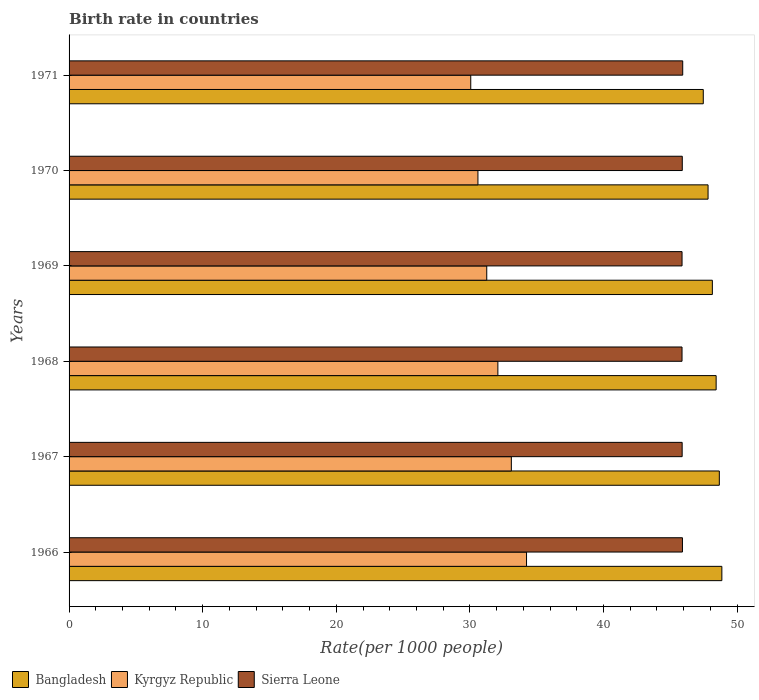What is the label of the 4th group of bars from the top?
Your answer should be compact. 1968. What is the birth rate in Kyrgyz Republic in 1971?
Provide a short and direct response. 30.06. Across all years, what is the maximum birth rate in Kyrgyz Republic?
Offer a terse response. 34.24. Across all years, what is the minimum birth rate in Sierra Leone?
Your response must be concise. 45.88. In which year was the birth rate in Kyrgyz Republic maximum?
Your answer should be compact. 1966. What is the total birth rate in Bangladesh in the graph?
Your response must be concise. 289.39. What is the difference between the birth rate in Kyrgyz Republic in 1969 and that in 1971?
Ensure brevity in your answer.  1.2. What is the difference between the birth rate in Bangladesh in 1967 and the birth rate in Sierra Leone in 1968?
Make the answer very short. 2.79. What is the average birth rate in Sierra Leone per year?
Ensure brevity in your answer.  45.9. In the year 1970, what is the difference between the birth rate in Kyrgyz Republic and birth rate in Bangladesh?
Your response must be concise. -17.22. What is the ratio of the birth rate in Bangladesh in 1967 to that in 1971?
Keep it short and to the point. 1.03. Is the birth rate in Kyrgyz Republic in 1967 less than that in 1970?
Keep it short and to the point. No. What is the difference between the highest and the second highest birth rate in Kyrgyz Republic?
Offer a very short reply. 1.14. What is the difference between the highest and the lowest birth rate in Sierra Leone?
Offer a terse response. 0.05. In how many years, is the birth rate in Kyrgyz Republic greater than the average birth rate in Kyrgyz Republic taken over all years?
Keep it short and to the point. 3. Is the sum of the birth rate in Kyrgyz Republic in 1966 and 1971 greater than the maximum birth rate in Bangladesh across all years?
Offer a terse response. Yes. What does the 2nd bar from the bottom in 1968 represents?
Make the answer very short. Kyrgyz Republic. Does the graph contain grids?
Offer a very short reply. No. Where does the legend appear in the graph?
Your response must be concise. Bottom left. How are the legend labels stacked?
Offer a terse response. Horizontal. What is the title of the graph?
Ensure brevity in your answer.  Birth rate in countries. What is the label or title of the X-axis?
Your response must be concise. Rate(per 1000 people). What is the Rate(per 1000 people) in Bangladesh in 1966?
Offer a terse response. 48.86. What is the Rate(per 1000 people) in Kyrgyz Republic in 1966?
Ensure brevity in your answer.  34.24. What is the Rate(per 1000 people) in Sierra Leone in 1966?
Your answer should be compact. 45.91. What is the Rate(per 1000 people) of Bangladesh in 1967?
Your response must be concise. 48.67. What is the Rate(per 1000 people) of Kyrgyz Republic in 1967?
Provide a short and direct response. 33.1. What is the Rate(per 1000 people) in Sierra Leone in 1967?
Ensure brevity in your answer.  45.89. What is the Rate(per 1000 people) in Bangladesh in 1968?
Provide a succinct answer. 48.43. What is the Rate(per 1000 people) in Kyrgyz Republic in 1968?
Provide a short and direct response. 32.09. What is the Rate(per 1000 people) in Sierra Leone in 1968?
Your answer should be compact. 45.88. What is the Rate(per 1000 people) of Bangladesh in 1969?
Offer a terse response. 48.15. What is the Rate(per 1000 people) in Kyrgyz Republic in 1969?
Offer a terse response. 31.26. What is the Rate(per 1000 people) in Sierra Leone in 1969?
Give a very brief answer. 45.88. What is the Rate(per 1000 people) of Bangladesh in 1970?
Give a very brief answer. 47.83. What is the Rate(per 1000 people) of Kyrgyz Republic in 1970?
Provide a succinct answer. 30.6. What is the Rate(per 1000 people) of Sierra Leone in 1970?
Keep it short and to the point. 45.9. What is the Rate(per 1000 people) of Bangladesh in 1971?
Give a very brief answer. 47.47. What is the Rate(per 1000 people) of Kyrgyz Republic in 1971?
Your response must be concise. 30.06. What is the Rate(per 1000 people) in Sierra Leone in 1971?
Your answer should be very brief. 45.93. Across all years, what is the maximum Rate(per 1000 people) in Bangladesh?
Give a very brief answer. 48.86. Across all years, what is the maximum Rate(per 1000 people) of Kyrgyz Republic?
Ensure brevity in your answer.  34.24. Across all years, what is the maximum Rate(per 1000 people) of Sierra Leone?
Offer a terse response. 45.93. Across all years, what is the minimum Rate(per 1000 people) of Bangladesh?
Your answer should be very brief. 47.47. Across all years, what is the minimum Rate(per 1000 people) in Kyrgyz Republic?
Keep it short and to the point. 30.06. Across all years, what is the minimum Rate(per 1000 people) of Sierra Leone?
Your answer should be compact. 45.88. What is the total Rate(per 1000 people) of Bangladesh in the graph?
Your response must be concise. 289.39. What is the total Rate(per 1000 people) in Kyrgyz Republic in the graph?
Offer a very short reply. 191.36. What is the total Rate(per 1000 people) of Sierra Leone in the graph?
Make the answer very short. 275.37. What is the difference between the Rate(per 1000 people) of Bangladesh in 1966 and that in 1967?
Ensure brevity in your answer.  0.19. What is the difference between the Rate(per 1000 people) of Kyrgyz Republic in 1966 and that in 1967?
Ensure brevity in your answer.  1.14. What is the difference between the Rate(per 1000 people) of Sierra Leone in 1966 and that in 1967?
Provide a short and direct response. 0.02. What is the difference between the Rate(per 1000 people) in Bangladesh in 1966 and that in 1968?
Your answer should be compact. 0.43. What is the difference between the Rate(per 1000 people) of Kyrgyz Republic in 1966 and that in 1968?
Keep it short and to the point. 2.15. What is the difference between the Rate(per 1000 people) in Sierra Leone in 1966 and that in 1968?
Your answer should be very brief. 0.03. What is the difference between the Rate(per 1000 people) of Bangladesh in 1966 and that in 1969?
Provide a short and direct response. 0.71. What is the difference between the Rate(per 1000 people) of Kyrgyz Republic in 1966 and that in 1969?
Make the answer very short. 2.98. What is the difference between the Rate(per 1000 people) of Sierra Leone in 1966 and that in 1969?
Your response must be concise. 0.03. What is the difference between the Rate(per 1000 people) in Bangladesh in 1966 and that in 1970?
Your answer should be compact. 1.03. What is the difference between the Rate(per 1000 people) in Kyrgyz Republic in 1966 and that in 1970?
Your response must be concise. 3.64. What is the difference between the Rate(per 1000 people) in Sierra Leone in 1966 and that in 1970?
Give a very brief answer. 0.01. What is the difference between the Rate(per 1000 people) of Bangladesh in 1966 and that in 1971?
Your answer should be compact. 1.39. What is the difference between the Rate(per 1000 people) in Kyrgyz Republic in 1966 and that in 1971?
Your answer should be very brief. 4.17. What is the difference between the Rate(per 1000 people) in Sierra Leone in 1966 and that in 1971?
Offer a terse response. -0.02. What is the difference between the Rate(per 1000 people) of Bangladesh in 1967 and that in 1968?
Make the answer very short. 0.24. What is the difference between the Rate(per 1000 people) in Kyrgyz Republic in 1967 and that in 1968?
Your answer should be compact. 1.01. What is the difference between the Rate(per 1000 people) of Sierra Leone in 1967 and that in 1968?
Give a very brief answer. 0.01. What is the difference between the Rate(per 1000 people) of Bangladesh in 1967 and that in 1969?
Your answer should be compact. 0.52. What is the difference between the Rate(per 1000 people) of Kyrgyz Republic in 1967 and that in 1969?
Offer a very short reply. 1.84. What is the difference between the Rate(per 1000 people) in Sierra Leone in 1967 and that in 1969?
Your response must be concise. 0.01. What is the difference between the Rate(per 1000 people) of Bangladesh in 1967 and that in 1970?
Ensure brevity in your answer.  0.84. What is the difference between the Rate(per 1000 people) of Kyrgyz Republic in 1967 and that in 1970?
Your response must be concise. 2.5. What is the difference between the Rate(per 1000 people) of Sierra Leone in 1967 and that in 1970?
Make the answer very short. -0.01. What is the difference between the Rate(per 1000 people) of Bangladesh in 1967 and that in 1971?
Give a very brief answer. 1.2. What is the difference between the Rate(per 1000 people) in Kyrgyz Republic in 1967 and that in 1971?
Make the answer very short. 3.04. What is the difference between the Rate(per 1000 people) in Sierra Leone in 1967 and that in 1971?
Your answer should be compact. -0.04. What is the difference between the Rate(per 1000 people) in Bangladesh in 1968 and that in 1969?
Ensure brevity in your answer.  0.28. What is the difference between the Rate(per 1000 people) in Kyrgyz Republic in 1968 and that in 1969?
Your answer should be very brief. 0.83. What is the difference between the Rate(per 1000 people) in Sierra Leone in 1968 and that in 1969?
Provide a short and direct response. -0. What is the difference between the Rate(per 1000 people) in Bangladesh in 1968 and that in 1970?
Ensure brevity in your answer.  0.6. What is the difference between the Rate(per 1000 people) of Kyrgyz Republic in 1968 and that in 1970?
Provide a short and direct response. 1.49. What is the difference between the Rate(per 1000 people) in Sierra Leone in 1968 and that in 1970?
Provide a short and direct response. -0.02. What is the difference between the Rate(per 1000 people) in Kyrgyz Republic in 1968 and that in 1971?
Offer a very short reply. 2.03. What is the difference between the Rate(per 1000 people) in Sierra Leone in 1968 and that in 1971?
Provide a succinct answer. -0.05. What is the difference between the Rate(per 1000 people) of Bangladesh in 1969 and that in 1970?
Offer a terse response. 0.32. What is the difference between the Rate(per 1000 people) in Kyrgyz Republic in 1969 and that in 1970?
Your response must be concise. 0.66. What is the difference between the Rate(per 1000 people) in Sierra Leone in 1969 and that in 1970?
Your answer should be compact. -0.02. What is the difference between the Rate(per 1000 people) in Bangladesh in 1969 and that in 1971?
Your response must be concise. 0.68. What is the difference between the Rate(per 1000 people) in Kyrgyz Republic in 1969 and that in 1971?
Offer a very short reply. 1.2. What is the difference between the Rate(per 1000 people) of Bangladesh in 1970 and that in 1971?
Your answer should be compact. 0.36. What is the difference between the Rate(per 1000 people) of Kyrgyz Republic in 1970 and that in 1971?
Keep it short and to the point. 0.54. What is the difference between the Rate(per 1000 people) in Sierra Leone in 1970 and that in 1971?
Your response must be concise. -0.03. What is the difference between the Rate(per 1000 people) of Bangladesh in 1966 and the Rate(per 1000 people) of Kyrgyz Republic in 1967?
Ensure brevity in your answer.  15.76. What is the difference between the Rate(per 1000 people) of Bangladesh in 1966 and the Rate(per 1000 people) of Sierra Leone in 1967?
Provide a succinct answer. 2.97. What is the difference between the Rate(per 1000 people) in Kyrgyz Republic in 1966 and the Rate(per 1000 people) in Sierra Leone in 1967?
Ensure brevity in your answer.  -11.65. What is the difference between the Rate(per 1000 people) in Bangladesh in 1966 and the Rate(per 1000 people) in Kyrgyz Republic in 1968?
Provide a short and direct response. 16.76. What is the difference between the Rate(per 1000 people) in Bangladesh in 1966 and the Rate(per 1000 people) in Sierra Leone in 1968?
Provide a short and direct response. 2.98. What is the difference between the Rate(per 1000 people) of Kyrgyz Republic in 1966 and the Rate(per 1000 people) of Sierra Leone in 1968?
Provide a succinct answer. -11.64. What is the difference between the Rate(per 1000 people) in Bangladesh in 1966 and the Rate(per 1000 people) in Kyrgyz Republic in 1969?
Give a very brief answer. 17.6. What is the difference between the Rate(per 1000 people) in Bangladesh in 1966 and the Rate(per 1000 people) in Sierra Leone in 1969?
Make the answer very short. 2.98. What is the difference between the Rate(per 1000 people) of Kyrgyz Republic in 1966 and the Rate(per 1000 people) of Sierra Leone in 1969?
Ensure brevity in your answer.  -11.64. What is the difference between the Rate(per 1000 people) in Bangladesh in 1966 and the Rate(per 1000 people) in Kyrgyz Republic in 1970?
Keep it short and to the point. 18.26. What is the difference between the Rate(per 1000 people) of Bangladesh in 1966 and the Rate(per 1000 people) of Sierra Leone in 1970?
Give a very brief answer. 2.96. What is the difference between the Rate(per 1000 people) in Kyrgyz Republic in 1966 and the Rate(per 1000 people) in Sierra Leone in 1970?
Make the answer very short. -11.66. What is the difference between the Rate(per 1000 people) of Bangladesh in 1966 and the Rate(per 1000 people) of Kyrgyz Republic in 1971?
Your answer should be compact. 18.79. What is the difference between the Rate(per 1000 people) in Bangladesh in 1966 and the Rate(per 1000 people) in Sierra Leone in 1971?
Keep it short and to the point. 2.93. What is the difference between the Rate(per 1000 people) of Kyrgyz Republic in 1966 and the Rate(per 1000 people) of Sierra Leone in 1971?
Provide a succinct answer. -11.69. What is the difference between the Rate(per 1000 people) in Bangladesh in 1967 and the Rate(per 1000 people) in Kyrgyz Republic in 1968?
Your answer should be compact. 16.57. What is the difference between the Rate(per 1000 people) of Bangladesh in 1967 and the Rate(per 1000 people) of Sierra Leone in 1968?
Make the answer very short. 2.79. What is the difference between the Rate(per 1000 people) of Kyrgyz Republic in 1967 and the Rate(per 1000 people) of Sierra Leone in 1968?
Your answer should be very brief. -12.78. What is the difference between the Rate(per 1000 people) in Bangladesh in 1967 and the Rate(per 1000 people) in Kyrgyz Republic in 1969?
Make the answer very short. 17.41. What is the difference between the Rate(per 1000 people) in Bangladesh in 1967 and the Rate(per 1000 people) in Sierra Leone in 1969?
Provide a succinct answer. 2.79. What is the difference between the Rate(per 1000 people) in Kyrgyz Republic in 1967 and the Rate(per 1000 people) in Sierra Leone in 1969?
Keep it short and to the point. -12.78. What is the difference between the Rate(per 1000 people) of Bangladesh in 1967 and the Rate(per 1000 people) of Kyrgyz Republic in 1970?
Make the answer very short. 18.07. What is the difference between the Rate(per 1000 people) of Bangladesh in 1967 and the Rate(per 1000 people) of Sierra Leone in 1970?
Offer a terse response. 2.77. What is the difference between the Rate(per 1000 people) of Kyrgyz Republic in 1967 and the Rate(per 1000 people) of Sierra Leone in 1970?
Offer a terse response. -12.79. What is the difference between the Rate(per 1000 people) of Bangladesh in 1967 and the Rate(per 1000 people) of Kyrgyz Republic in 1971?
Your answer should be very brief. 18.61. What is the difference between the Rate(per 1000 people) in Bangladesh in 1967 and the Rate(per 1000 people) in Sierra Leone in 1971?
Offer a terse response. 2.74. What is the difference between the Rate(per 1000 people) in Kyrgyz Republic in 1967 and the Rate(per 1000 people) in Sierra Leone in 1971?
Your response must be concise. -12.83. What is the difference between the Rate(per 1000 people) of Bangladesh in 1968 and the Rate(per 1000 people) of Kyrgyz Republic in 1969?
Your answer should be compact. 17.17. What is the difference between the Rate(per 1000 people) of Bangladesh in 1968 and the Rate(per 1000 people) of Sierra Leone in 1969?
Your answer should be very brief. 2.55. What is the difference between the Rate(per 1000 people) in Kyrgyz Republic in 1968 and the Rate(per 1000 people) in Sierra Leone in 1969?
Your answer should be very brief. -13.79. What is the difference between the Rate(per 1000 people) in Bangladesh in 1968 and the Rate(per 1000 people) in Kyrgyz Republic in 1970?
Provide a succinct answer. 17.83. What is the difference between the Rate(per 1000 people) in Bangladesh in 1968 and the Rate(per 1000 people) in Sierra Leone in 1970?
Keep it short and to the point. 2.54. What is the difference between the Rate(per 1000 people) in Kyrgyz Republic in 1968 and the Rate(per 1000 people) in Sierra Leone in 1970?
Your answer should be very brief. -13.8. What is the difference between the Rate(per 1000 people) of Bangladesh in 1968 and the Rate(per 1000 people) of Kyrgyz Republic in 1971?
Your answer should be compact. 18.37. What is the difference between the Rate(per 1000 people) in Bangladesh in 1968 and the Rate(per 1000 people) in Sierra Leone in 1971?
Offer a terse response. 2.5. What is the difference between the Rate(per 1000 people) in Kyrgyz Republic in 1968 and the Rate(per 1000 people) in Sierra Leone in 1971?
Make the answer very short. -13.84. What is the difference between the Rate(per 1000 people) in Bangladesh in 1969 and the Rate(per 1000 people) in Kyrgyz Republic in 1970?
Keep it short and to the point. 17.55. What is the difference between the Rate(per 1000 people) in Bangladesh in 1969 and the Rate(per 1000 people) in Sierra Leone in 1970?
Keep it short and to the point. 2.25. What is the difference between the Rate(per 1000 people) in Kyrgyz Republic in 1969 and the Rate(per 1000 people) in Sierra Leone in 1970?
Keep it short and to the point. -14.63. What is the difference between the Rate(per 1000 people) of Bangladesh in 1969 and the Rate(per 1000 people) of Kyrgyz Republic in 1971?
Your answer should be compact. 18.08. What is the difference between the Rate(per 1000 people) of Bangladesh in 1969 and the Rate(per 1000 people) of Sierra Leone in 1971?
Ensure brevity in your answer.  2.22. What is the difference between the Rate(per 1000 people) of Kyrgyz Republic in 1969 and the Rate(per 1000 people) of Sierra Leone in 1971?
Give a very brief answer. -14.67. What is the difference between the Rate(per 1000 people) of Bangladesh in 1970 and the Rate(per 1000 people) of Kyrgyz Republic in 1971?
Offer a very short reply. 17.76. What is the difference between the Rate(per 1000 people) of Bangladesh in 1970 and the Rate(per 1000 people) of Sierra Leone in 1971?
Your answer should be compact. 1.9. What is the difference between the Rate(per 1000 people) of Kyrgyz Republic in 1970 and the Rate(per 1000 people) of Sierra Leone in 1971?
Your answer should be compact. -15.33. What is the average Rate(per 1000 people) of Bangladesh per year?
Your response must be concise. 48.23. What is the average Rate(per 1000 people) of Kyrgyz Republic per year?
Keep it short and to the point. 31.89. What is the average Rate(per 1000 people) in Sierra Leone per year?
Offer a terse response. 45.9. In the year 1966, what is the difference between the Rate(per 1000 people) of Bangladesh and Rate(per 1000 people) of Kyrgyz Republic?
Provide a succinct answer. 14.62. In the year 1966, what is the difference between the Rate(per 1000 people) in Bangladesh and Rate(per 1000 people) in Sierra Leone?
Make the answer very short. 2.95. In the year 1966, what is the difference between the Rate(per 1000 people) of Kyrgyz Republic and Rate(per 1000 people) of Sierra Leone?
Provide a succinct answer. -11.67. In the year 1967, what is the difference between the Rate(per 1000 people) in Bangladesh and Rate(per 1000 people) in Kyrgyz Republic?
Your answer should be very brief. 15.57. In the year 1967, what is the difference between the Rate(per 1000 people) in Bangladesh and Rate(per 1000 people) in Sierra Leone?
Keep it short and to the point. 2.78. In the year 1967, what is the difference between the Rate(per 1000 people) in Kyrgyz Republic and Rate(per 1000 people) in Sierra Leone?
Provide a succinct answer. -12.79. In the year 1968, what is the difference between the Rate(per 1000 people) in Bangladesh and Rate(per 1000 people) in Kyrgyz Republic?
Provide a succinct answer. 16.34. In the year 1968, what is the difference between the Rate(per 1000 people) in Bangladesh and Rate(per 1000 people) in Sierra Leone?
Provide a short and direct response. 2.55. In the year 1968, what is the difference between the Rate(per 1000 people) of Kyrgyz Republic and Rate(per 1000 people) of Sierra Leone?
Give a very brief answer. -13.78. In the year 1969, what is the difference between the Rate(per 1000 people) in Bangladesh and Rate(per 1000 people) in Kyrgyz Republic?
Your response must be concise. 16.89. In the year 1969, what is the difference between the Rate(per 1000 people) of Bangladesh and Rate(per 1000 people) of Sierra Leone?
Offer a very short reply. 2.27. In the year 1969, what is the difference between the Rate(per 1000 people) in Kyrgyz Republic and Rate(per 1000 people) in Sierra Leone?
Offer a very short reply. -14.62. In the year 1970, what is the difference between the Rate(per 1000 people) in Bangladesh and Rate(per 1000 people) in Kyrgyz Republic?
Keep it short and to the point. 17.22. In the year 1970, what is the difference between the Rate(per 1000 people) in Bangladesh and Rate(per 1000 people) in Sierra Leone?
Provide a succinct answer. 1.93. In the year 1970, what is the difference between the Rate(per 1000 people) in Kyrgyz Republic and Rate(per 1000 people) in Sierra Leone?
Your answer should be compact. -15.29. In the year 1971, what is the difference between the Rate(per 1000 people) of Bangladesh and Rate(per 1000 people) of Kyrgyz Republic?
Offer a terse response. 17.4. In the year 1971, what is the difference between the Rate(per 1000 people) of Bangladesh and Rate(per 1000 people) of Sierra Leone?
Your answer should be compact. 1.54. In the year 1971, what is the difference between the Rate(per 1000 people) in Kyrgyz Republic and Rate(per 1000 people) in Sierra Leone?
Your answer should be very brief. -15.87. What is the ratio of the Rate(per 1000 people) of Kyrgyz Republic in 1966 to that in 1967?
Your answer should be compact. 1.03. What is the ratio of the Rate(per 1000 people) in Bangladesh in 1966 to that in 1968?
Your answer should be compact. 1.01. What is the ratio of the Rate(per 1000 people) of Kyrgyz Republic in 1966 to that in 1968?
Your answer should be compact. 1.07. What is the ratio of the Rate(per 1000 people) in Bangladesh in 1966 to that in 1969?
Offer a very short reply. 1.01. What is the ratio of the Rate(per 1000 people) of Kyrgyz Republic in 1966 to that in 1969?
Provide a succinct answer. 1.1. What is the ratio of the Rate(per 1000 people) of Bangladesh in 1966 to that in 1970?
Keep it short and to the point. 1.02. What is the ratio of the Rate(per 1000 people) of Kyrgyz Republic in 1966 to that in 1970?
Offer a very short reply. 1.12. What is the ratio of the Rate(per 1000 people) in Sierra Leone in 1966 to that in 1970?
Your answer should be compact. 1. What is the ratio of the Rate(per 1000 people) in Bangladesh in 1966 to that in 1971?
Your answer should be very brief. 1.03. What is the ratio of the Rate(per 1000 people) in Kyrgyz Republic in 1966 to that in 1971?
Offer a very short reply. 1.14. What is the ratio of the Rate(per 1000 people) of Sierra Leone in 1966 to that in 1971?
Provide a succinct answer. 1. What is the ratio of the Rate(per 1000 people) of Kyrgyz Republic in 1967 to that in 1968?
Your answer should be compact. 1.03. What is the ratio of the Rate(per 1000 people) of Bangladesh in 1967 to that in 1969?
Ensure brevity in your answer.  1.01. What is the ratio of the Rate(per 1000 people) in Kyrgyz Republic in 1967 to that in 1969?
Your response must be concise. 1.06. What is the ratio of the Rate(per 1000 people) in Bangladesh in 1967 to that in 1970?
Make the answer very short. 1.02. What is the ratio of the Rate(per 1000 people) of Kyrgyz Republic in 1967 to that in 1970?
Offer a very short reply. 1.08. What is the ratio of the Rate(per 1000 people) of Sierra Leone in 1967 to that in 1970?
Your answer should be very brief. 1. What is the ratio of the Rate(per 1000 people) of Bangladesh in 1967 to that in 1971?
Give a very brief answer. 1.03. What is the ratio of the Rate(per 1000 people) of Kyrgyz Republic in 1967 to that in 1971?
Ensure brevity in your answer.  1.1. What is the ratio of the Rate(per 1000 people) of Sierra Leone in 1967 to that in 1971?
Provide a short and direct response. 1. What is the ratio of the Rate(per 1000 people) in Bangladesh in 1968 to that in 1969?
Offer a terse response. 1.01. What is the ratio of the Rate(per 1000 people) of Kyrgyz Republic in 1968 to that in 1969?
Keep it short and to the point. 1.03. What is the ratio of the Rate(per 1000 people) in Sierra Leone in 1968 to that in 1969?
Your answer should be compact. 1. What is the ratio of the Rate(per 1000 people) of Bangladesh in 1968 to that in 1970?
Make the answer very short. 1.01. What is the ratio of the Rate(per 1000 people) in Kyrgyz Republic in 1968 to that in 1970?
Provide a short and direct response. 1.05. What is the ratio of the Rate(per 1000 people) in Bangladesh in 1968 to that in 1971?
Keep it short and to the point. 1.02. What is the ratio of the Rate(per 1000 people) of Kyrgyz Republic in 1968 to that in 1971?
Give a very brief answer. 1.07. What is the ratio of the Rate(per 1000 people) in Kyrgyz Republic in 1969 to that in 1970?
Your answer should be compact. 1.02. What is the ratio of the Rate(per 1000 people) in Sierra Leone in 1969 to that in 1970?
Give a very brief answer. 1. What is the ratio of the Rate(per 1000 people) of Bangladesh in 1969 to that in 1971?
Offer a very short reply. 1.01. What is the ratio of the Rate(per 1000 people) in Kyrgyz Republic in 1969 to that in 1971?
Offer a very short reply. 1.04. What is the ratio of the Rate(per 1000 people) in Bangladesh in 1970 to that in 1971?
Offer a terse response. 1.01. What is the ratio of the Rate(per 1000 people) of Kyrgyz Republic in 1970 to that in 1971?
Offer a very short reply. 1.02. What is the difference between the highest and the second highest Rate(per 1000 people) of Bangladesh?
Ensure brevity in your answer.  0.19. What is the difference between the highest and the second highest Rate(per 1000 people) in Kyrgyz Republic?
Offer a very short reply. 1.14. What is the difference between the highest and the lowest Rate(per 1000 people) of Bangladesh?
Offer a very short reply. 1.39. What is the difference between the highest and the lowest Rate(per 1000 people) of Kyrgyz Republic?
Offer a terse response. 4.17. What is the difference between the highest and the lowest Rate(per 1000 people) of Sierra Leone?
Ensure brevity in your answer.  0.05. 